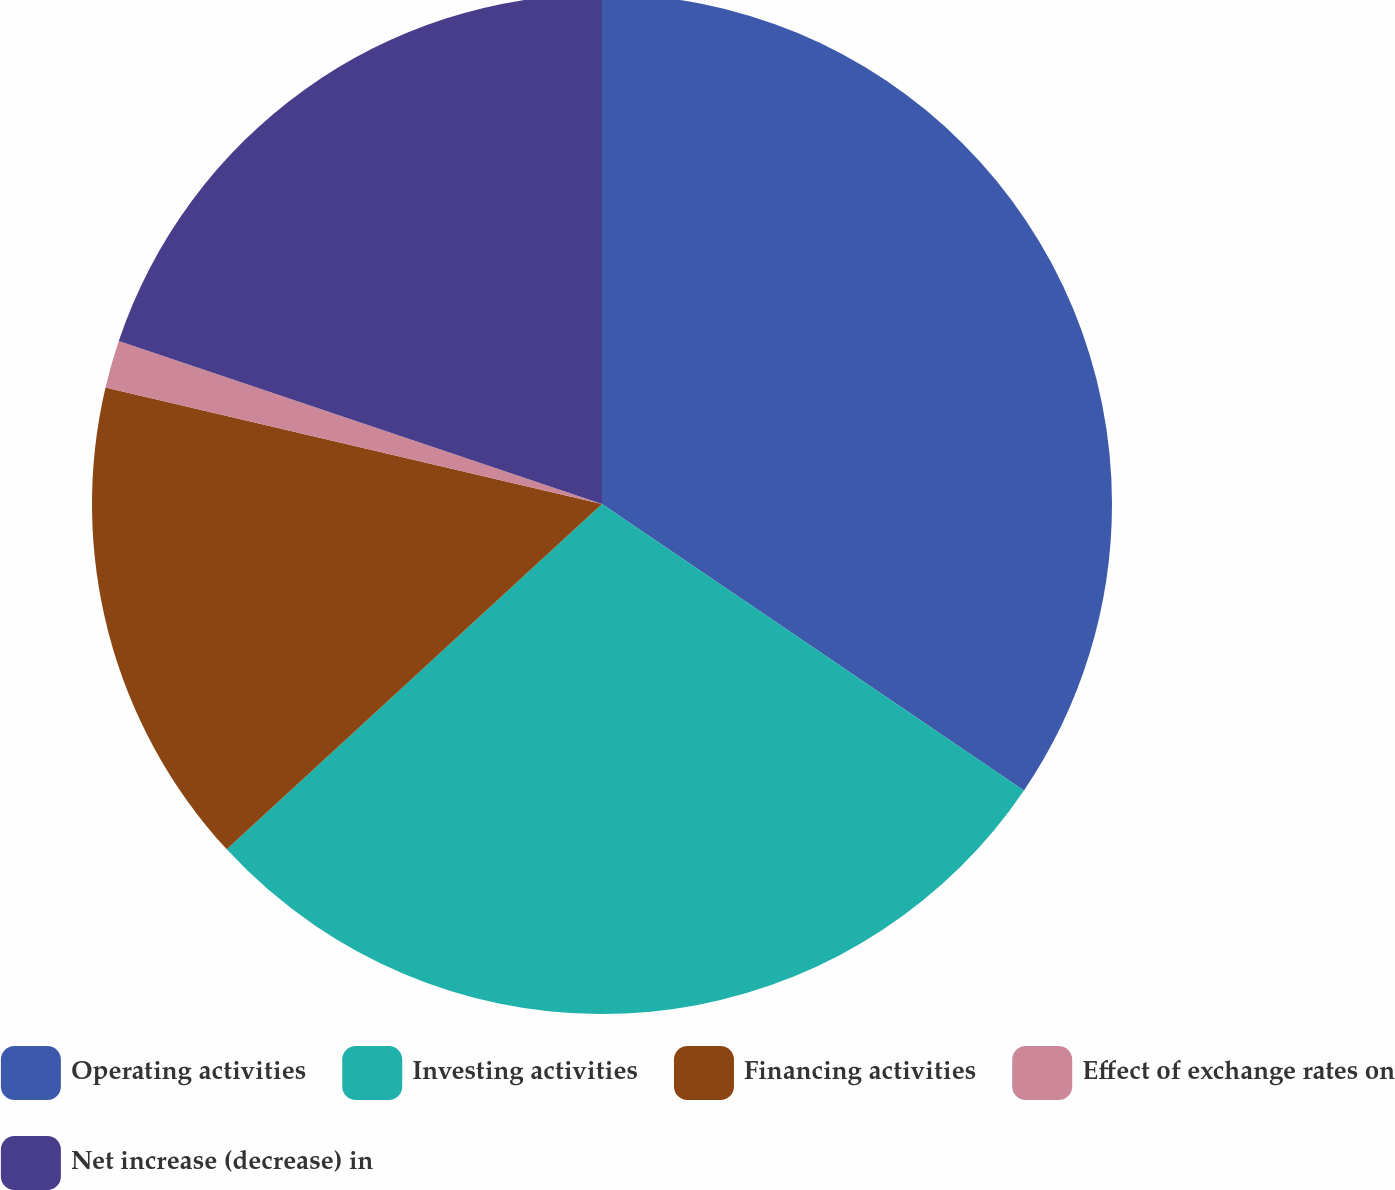<chart> <loc_0><loc_0><loc_500><loc_500><pie_chart><fcel>Operating activities<fcel>Investing activities<fcel>Financing activities<fcel>Effect of exchange rates on<fcel>Net increase (decrease) in<nl><fcel>34.49%<fcel>28.67%<fcel>15.51%<fcel>1.51%<fcel>19.82%<nl></chart> 